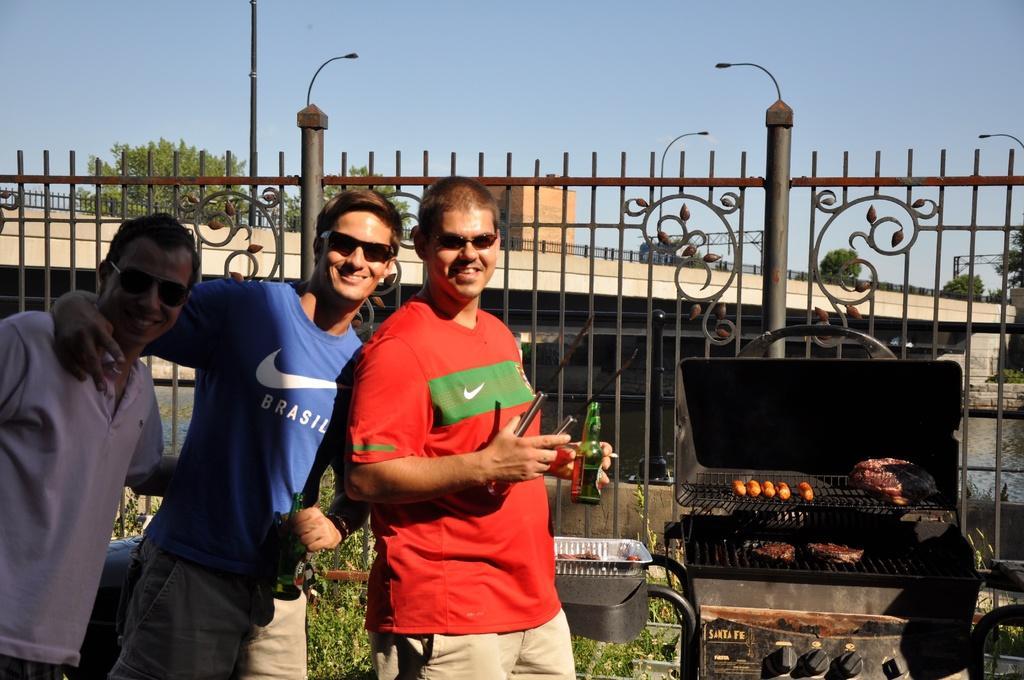Please provide a concise description of this image. In the picture I can see three men and there is a smile on their faces. I can see two men holding the glass bottle in their hand. I can see the outdoor grill rack and topper on the right side. I can see the metal fence. In the background, I can see the flyover and trees. 